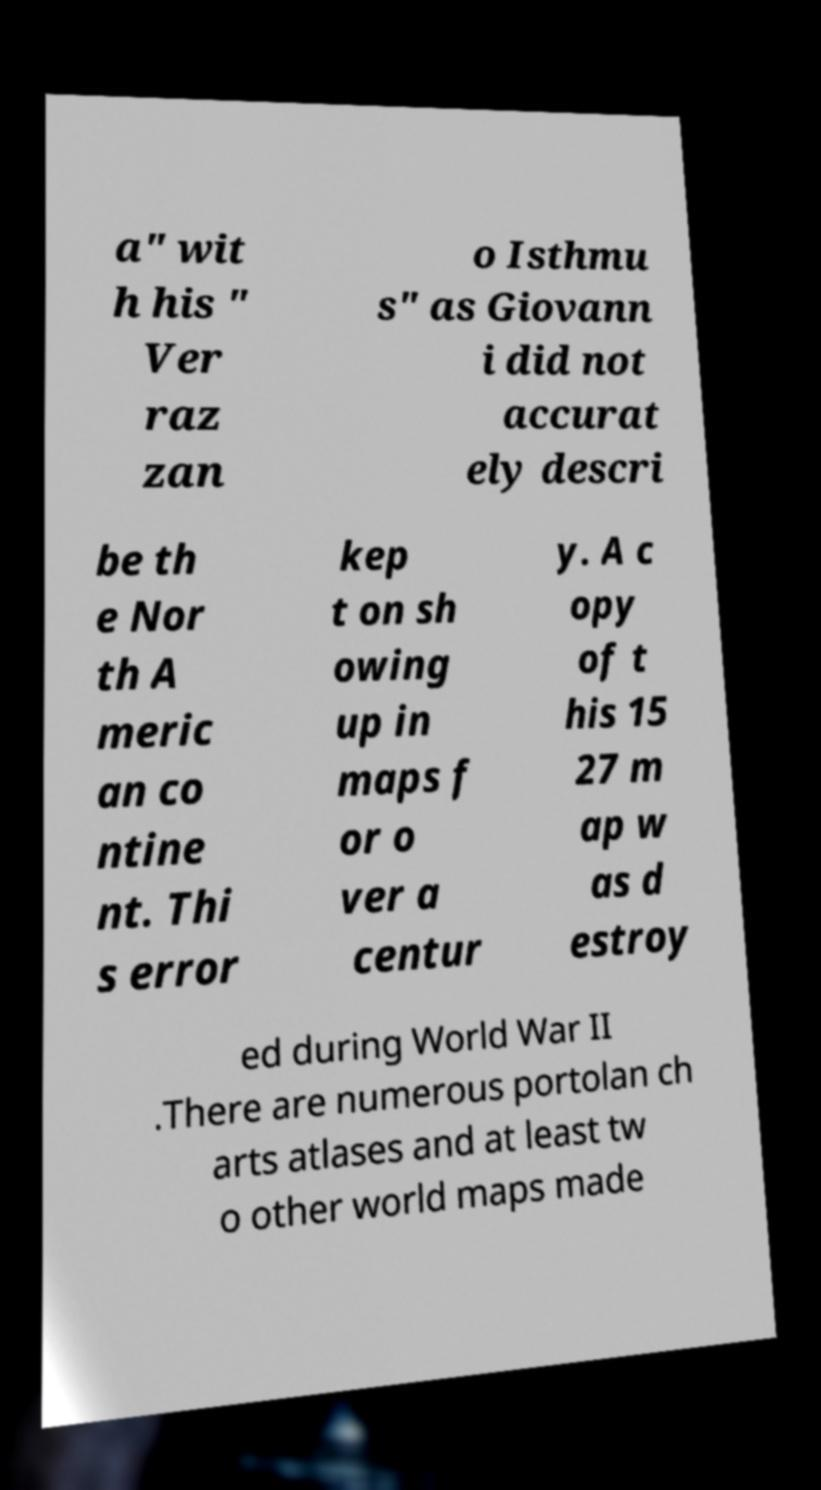For documentation purposes, I need the text within this image transcribed. Could you provide that? a" wit h his " Ver raz zan o Isthmu s" as Giovann i did not accurat ely descri be th e Nor th A meric an co ntine nt. Thi s error kep t on sh owing up in maps f or o ver a centur y. A c opy of t his 15 27 m ap w as d estroy ed during World War II .There are numerous portolan ch arts atlases and at least tw o other world maps made 